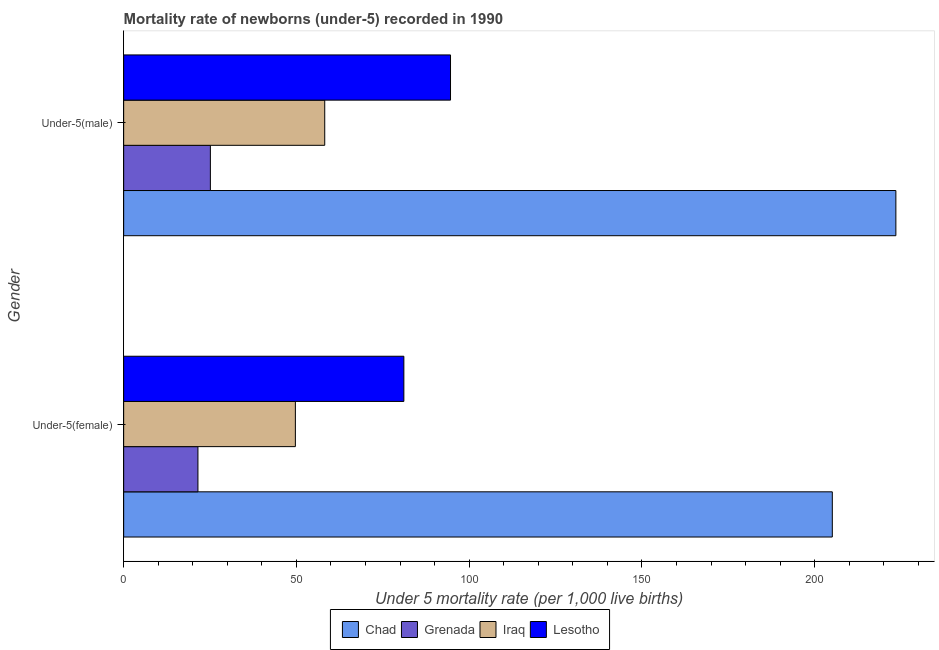How many groups of bars are there?
Your answer should be compact. 2. Are the number of bars per tick equal to the number of legend labels?
Provide a short and direct response. Yes. What is the label of the 1st group of bars from the top?
Ensure brevity in your answer.  Under-5(male). What is the under-5 male mortality rate in Lesotho?
Offer a terse response. 94.6. Across all countries, what is the maximum under-5 female mortality rate?
Make the answer very short. 205.1. Across all countries, what is the minimum under-5 female mortality rate?
Your answer should be compact. 21.5. In which country was the under-5 female mortality rate maximum?
Make the answer very short. Chad. In which country was the under-5 male mortality rate minimum?
Your response must be concise. Grenada. What is the total under-5 female mortality rate in the graph?
Keep it short and to the point. 357.4. What is the difference between the under-5 male mortality rate in Chad and that in Iraq?
Your answer should be compact. 165.3. What is the difference between the under-5 female mortality rate in Iraq and the under-5 male mortality rate in Grenada?
Offer a terse response. 24.6. What is the average under-5 female mortality rate per country?
Provide a succinct answer. 89.35. What is the difference between the under-5 female mortality rate and under-5 male mortality rate in Iraq?
Your response must be concise. -8.5. What is the ratio of the under-5 male mortality rate in Lesotho to that in Iraq?
Keep it short and to the point. 1.63. Is the under-5 male mortality rate in Iraq less than that in Lesotho?
Give a very brief answer. Yes. In how many countries, is the under-5 male mortality rate greater than the average under-5 male mortality rate taken over all countries?
Your answer should be compact. 1. What does the 2nd bar from the top in Under-5(female) represents?
Ensure brevity in your answer.  Iraq. What does the 1st bar from the bottom in Under-5(female) represents?
Provide a short and direct response. Chad. How many bars are there?
Keep it short and to the point. 8. Are all the bars in the graph horizontal?
Give a very brief answer. Yes. How many countries are there in the graph?
Your answer should be compact. 4. What is the difference between two consecutive major ticks on the X-axis?
Provide a short and direct response. 50. Are the values on the major ticks of X-axis written in scientific E-notation?
Ensure brevity in your answer.  No. Does the graph contain any zero values?
Offer a terse response. No. Where does the legend appear in the graph?
Make the answer very short. Bottom center. How many legend labels are there?
Ensure brevity in your answer.  4. What is the title of the graph?
Provide a short and direct response. Mortality rate of newborns (under-5) recorded in 1990. Does "Low & middle income" appear as one of the legend labels in the graph?
Provide a succinct answer. No. What is the label or title of the X-axis?
Offer a very short reply. Under 5 mortality rate (per 1,0 live births). What is the label or title of the Y-axis?
Offer a terse response. Gender. What is the Under 5 mortality rate (per 1,000 live births) in Chad in Under-5(female)?
Ensure brevity in your answer.  205.1. What is the Under 5 mortality rate (per 1,000 live births) of Grenada in Under-5(female)?
Provide a succinct answer. 21.5. What is the Under 5 mortality rate (per 1,000 live births) in Iraq in Under-5(female)?
Offer a very short reply. 49.7. What is the Under 5 mortality rate (per 1,000 live births) of Lesotho in Under-5(female)?
Provide a short and direct response. 81.1. What is the Under 5 mortality rate (per 1,000 live births) in Chad in Under-5(male)?
Your answer should be compact. 223.5. What is the Under 5 mortality rate (per 1,000 live births) of Grenada in Under-5(male)?
Ensure brevity in your answer.  25.1. What is the Under 5 mortality rate (per 1,000 live births) in Iraq in Under-5(male)?
Provide a short and direct response. 58.2. What is the Under 5 mortality rate (per 1,000 live births) of Lesotho in Under-5(male)?
Your answer should be very brief. 94.6. Across all Gender, what is the maximum Under 5 mortality rate (per 1,000 live births) in Chad?
Your response must be concise. 223.5. Across all Gender, what is the maximum Under 5 mortality rate (per 1,000 live births) in Grenada?
Your answer should be very brief. 25.1. Across all Gender, what is the maximum Under 5 mortality rate (per 1,000 live births) in Iraq?
Your answer should be compact. 58.2. Across all Gender, what is the maximum Under 5 mortality rate (per 1,000 live births) in Lesotho?
Make the answer very short. 94.6. Across all Gender, what is the minimum Under 5 mortality rate (per 1,000 live births) in Chad?
Make the answer very short. 205.1. Across all Gender, what is the minimum Under 5 mortality rate (per 1,000 live births) of Grenada?
Provide a short and direct response. 21.5. Across all Gender, what is the minimum Under 5 mortality rate (per 1,000 live births) in Iraq?
Keep it short and to the point. 49.7. Across all Gender, what is the minimum Under 5 mortality rate (per 1,000 live births) of Lesotho?
Provide a short and direct response. 81.1. What is the total Under 5 mortality rate (per 1,000 live births) in Chad in the graph?
Your response must be concise. 428.6. What is the total Under 5 mortality rate (per 1,000 live births) in Grenada in the graph?
Keep it short and to the point. 46.6. What is the total Under 5 mortality rate (per 1,000 live births) in Iraq in the graph?
Ensure brevity in your answer.  107.9. What is the total Under 5 mortality rate (per 1,000 live births) in Lesotho in the graph?
Your answer should be compact. 175.7. What is the difference between the Under 5 mortality rate (per 1,000 live births) of Chad in Under-5(female) and that in Under-5(male)?
Provide a short and direct response. -18.4. What is the difference between the Under 5 mortality rate (per 1,000 live births) in Lesotho in Under-5(female) and that in Under-5(male)?
Give a very brief answer. -13.5. What is the difference between the Under 5 mortality rate (per 1,000 live births) in Chad in Under-5(female) and the Under 5 mortality rate (per 1,000 live births) in Grenada in Under-5(male)?
Your response must be concise. 180. What is the difference between the Under 5 mortality rate (per 1,000 live births) of Chad in Under-5(female) and the Under 5 mortality rate (per 1,000 live births) of Iraq in Under-5(male)?
Offer a terse response. 146.9. What is the difference between the Under 5 mortality rate (per 1,000 live births) in Chad in Under-5(female) and the Under 5 mortality rate (per 1,000 live births) in Lesotho in Under-5(male)?
Offer a very short reply. 110.5. What is the difference between the Under 5 mortality rate (per 1,000 live births) in Grenada in Under-5(female) and the Under 5 mortality rate (per 1,000 live births) in Iraq in Under-5(male)?
Keep it short and to the point. -36.7. What is the difference between the Under 5 mortality rate (per 1,000 live births) of Grenada in Under-5(female) and the Under 5 mortality rate (per 1,000 live births) of Lesotho in Under-5(male)?
Ensure brevity in your answer.  -73.1. What is the difference between the Under 5 mortality rate (per 1,000 live births) of Iraq in Under-5(female) and the Under 5 mortality rate (per 1,000 live births) of Lesotho in Under-5(male)?
Your response must be concise. -44.9. What is the average Under 5 mortality rate (per 1,000 live births) of Chad per Gender?
Give a very brief answer. 214.3. What is the average Under 5 mortality rate (per 1,000 live births) of Grenada per Gender?
Provide a succinct answer. 23.3. What is the average Under 5 mortality rate (per 1,000 live births) of Iraq per Gender?
Your answer should be very brief. 53.95. What is the average Under 5 mortality rate (per 1,000 live births) in Lesotho per Gender?
Give a very brief answer. 87.85. What is the difference between the Under 5 mortality rate (per 1,000 live births) of Chad and Under 5 mortality rate (per 1,000 live births) of Grenada in Under-5(female)?
Your answer should be compact. 183.6. What is the difference between the Under 5 mortality rate (per 1,000 live births) in Chad and Under 5 mortality rate (per 1,000 live births) in Iraq in Under-5(female)?
Your response must be concise. 155.4. What is the difference between the Under 5 mortality rate (per 1,000 live births) in Chad and Under 5 mortality rate (per 1,000 live births) in Lesotho in Under-5(female)?
Provide a succinct answer. 124. What is the difference between the Under 5 mortality rate (per 1,000 live births) of Grenada and Under 5 mortality rate (per 1,000 live births) of Iraq in Under-5(female)?
Make the answer very short. -28.2. What is the difference between the Under 5 mortality rate (per 1,000 live births) of Grenada and Under 5 mortality rate (per 1,000 live births) of Lesotho in Under-5(female)?
Make the answer very short. -59.6. What is the difference between the Under 5 mortality rate (per 1,000 live births) in Iraq and Under 5 mortality rate (per 1,000 live births) in Lesotho in Under-5(female)?
Keep it short and to the point. -31.4. What is the difference between the Under 5 mortality rate (per 1,000 live births) in Chad and Under 5 mortality rate (per 1,000 live births) in Grenada in Under-5(male)?
Offer a very short reply. 198.4. What is the difference between the Under 5 mortality rate (per 1,000 live births) of Chad and Under 5 mortality rate (per 1,000 live births) of Iraq in Under-5(male)?
Provide a short and direct response. 165.3. What is the difference between the Under 5 mortality rate (per 1,000 live births) in Chad and Under 5 mortality rate (per 1,000 live births) in Lesotho in Under-5(male)?
Your answer should be compact. 128.9. What is the difference between the Under 5 mortality rate (per 1,000 live births) in Grenada and Under 5 mortality rate (per 1,000 live births) in Iraq in Under-5(male)?
Your answer should be very brief. -33.1. What is the difference between the Under 5 mortality rate (per 1,000 live births) in Grenada and Under 5 mortality rate (per 1,000 live births) in Lesotho in Under-5(male)?
Keep it short and to the point. -69.5. What is the difference between the Under 5 mortality rate (per 1,000 live births) in Iraq and Under 5 mortality rate (per 1,000 live births) in Lesotho in Under-5(male)?
Ensure brevity in your answer.  -36.4. What is the ratio of the Under 5 mortality rate (per 1,000 live births) in Chad in Under-5(female) to that in Under-5(male)?
Your answer should be very brief. 0.92. What is the ratio of the Under 5 mortality rate (per 1,000 live births) of Grenada in Under-5(female) to that in Under-5(male)?
Give a very brief answer. 0.86. What is the ratio of the Under 5 mortality rate (per 1,000 live births) of Iraq in Under-5(female) to that in Under-5(male)?
Keep it short and to the point. 0.85. What is the ratio of the Under 5 mortality rate (per 1,000 live births) in Lesotho in Under-5(female) to that in Under-5(male)?
Give a very brief answer. 0.86. What is the difference between the highest and the second highest Under 5 mortality rate (per 1,000 live births) in Grenada?
Offer a terse response. 3.6. What is the difference between the highest and the second highest Under 5 mortality rate (per 1,000 live births) in Iraq?
Keep it short and to the point. 8.5. What is the difference between the highest and the lowest Under 5 mortality rate (per 1,000 live births) in Lesotho?
Your response must be concise. 13.5. 